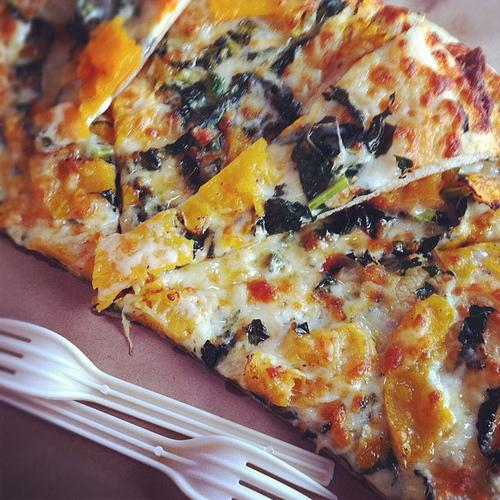Narrate the appearance of the pizza in the image. The pizza is topped with melted cheese, peppers, spinach, tomatoes, and has a thin crust with some browned areas. Describe the pizza toppings in a few words. Melted cheese, peppers, spinach, and tomato sauce garnish the pizza slice. Write a quick summary of the main elements in the image. The image shows a cheesy pizza with vegetables, two plastic forks, and a pinkish table. Mention the primary food item seen in the image along with some of its toppings. A delicious piece of pizza with gooey cheese, peppers, spinach, and tomatoes as toppings. Briefly highlight the main objects in the image. A pizza slice with various toppings, a pinkish table, and two white plastic forks are visible. Mention the key elements and the overall setting of the image. A mouthwatering pizza with diverse toppings, placed on a pinkish table along with two plastic forks. Express the image content in a poetic manner. A scrumptious, cheesy symphony of a pizza, atop a rosy table, accompanied by two plastic fork sentinels. Provide a concise description of the image. A sliced flat bread pizza with veggies and cheese, served on a pinkish table with white plastic forks. List down the subjects present in the image and the dominant color. Pizza, table, forks; dominant color: pinkish. What is the primary focus of the image and the secondary focus? Primary focus: a delicious piece of pizza; secondary focus: two white plastic forks and a pinkish table. 